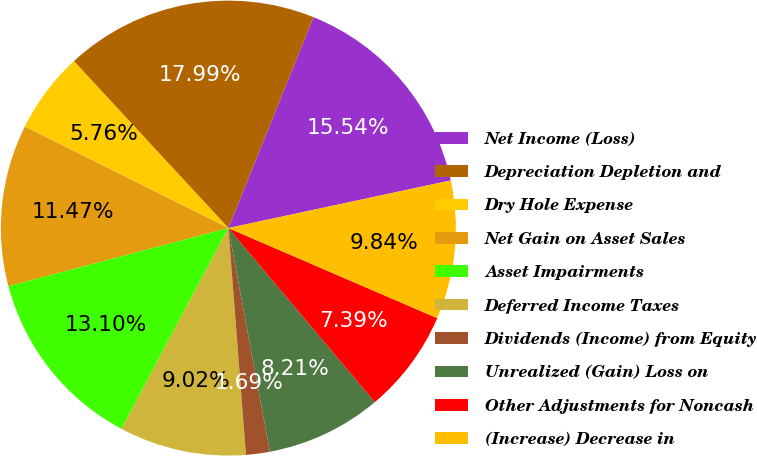Convert chart to OTSL. <chart><loc_0><loc_0><loc_500><loc_500><pie_chart><fcel>Net Income (Loss)<fcel>Depreciation Depletion and<fcel>Dry Hole Expense<fcel>Net Gain on Asset Sales<fcel>Asset Impairments<fcel>Deferred Income Taxes<fcel>Dividends (Income) from Equity<fcel>Unrealized (Gain) Loss on<fcel>Other Adjustments for Noncash<fcel>(Increase) Decrease in<nl><fcel>15.54%<fcel>17.99%<fcel>5.76%<fcel>11.47%<fcel>13.1%<fcel>9.02%<fcel>1.69%<fcel>8.21%<fcel>7.39%<fcel>9.84%<nl></chart> 